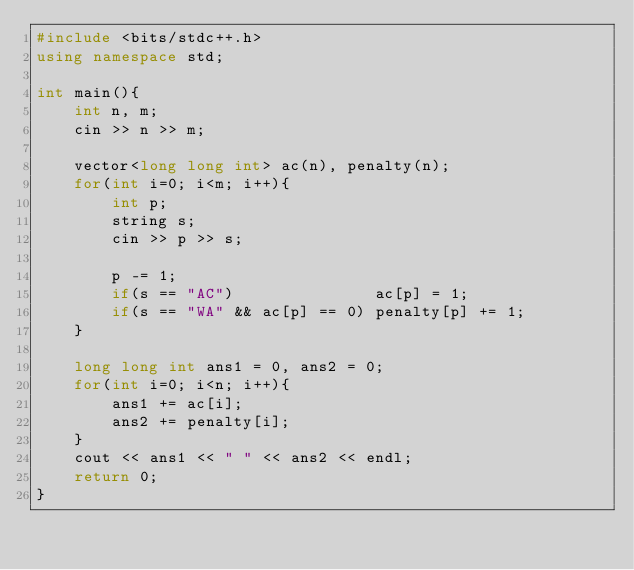Convert code to text. <code><loc_0><loc_0><loc_500><loc_500><_C++_>#include <bits/stdc++.h>
using namespace std;

int main(){
    int n, m;
    cin >> n >> m;

    vector<long long int> ac(n), penalty(n);
    for(int i=0; i<m; i++){
        int p;
        string s;
        cin >> p >> s;

        p -= 1;
        if(s == "AC")               ac[p] = 1;
        if(s == "WA" && ac[p] == 0) penalty[p] += 1;
    }

    long long int ans1 = 0, ans2 = 0;
    for(int i=0; i<n; i++){
        ans1 += ac[i];
        ans2 += penalty[i];
    }
    cout << ans1 << " " << ans2 << endl;
    return 0;
}</code> 